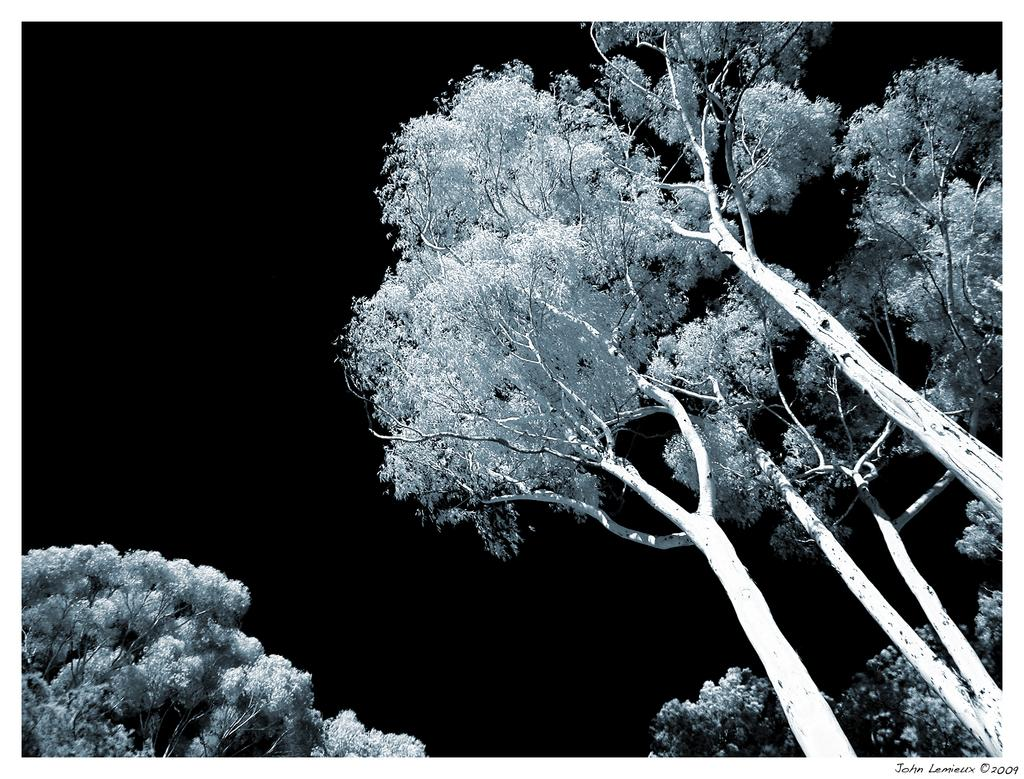What type of vegetation can be seen in the image? There are trees in the image. Can you describe the lighting conditions in the image? The image appears to be taken in a dark environment. What type of patch is visible on the tree in the image? There is no patch visible on the tree in the image, as it is not mentioned in the provided facts. 